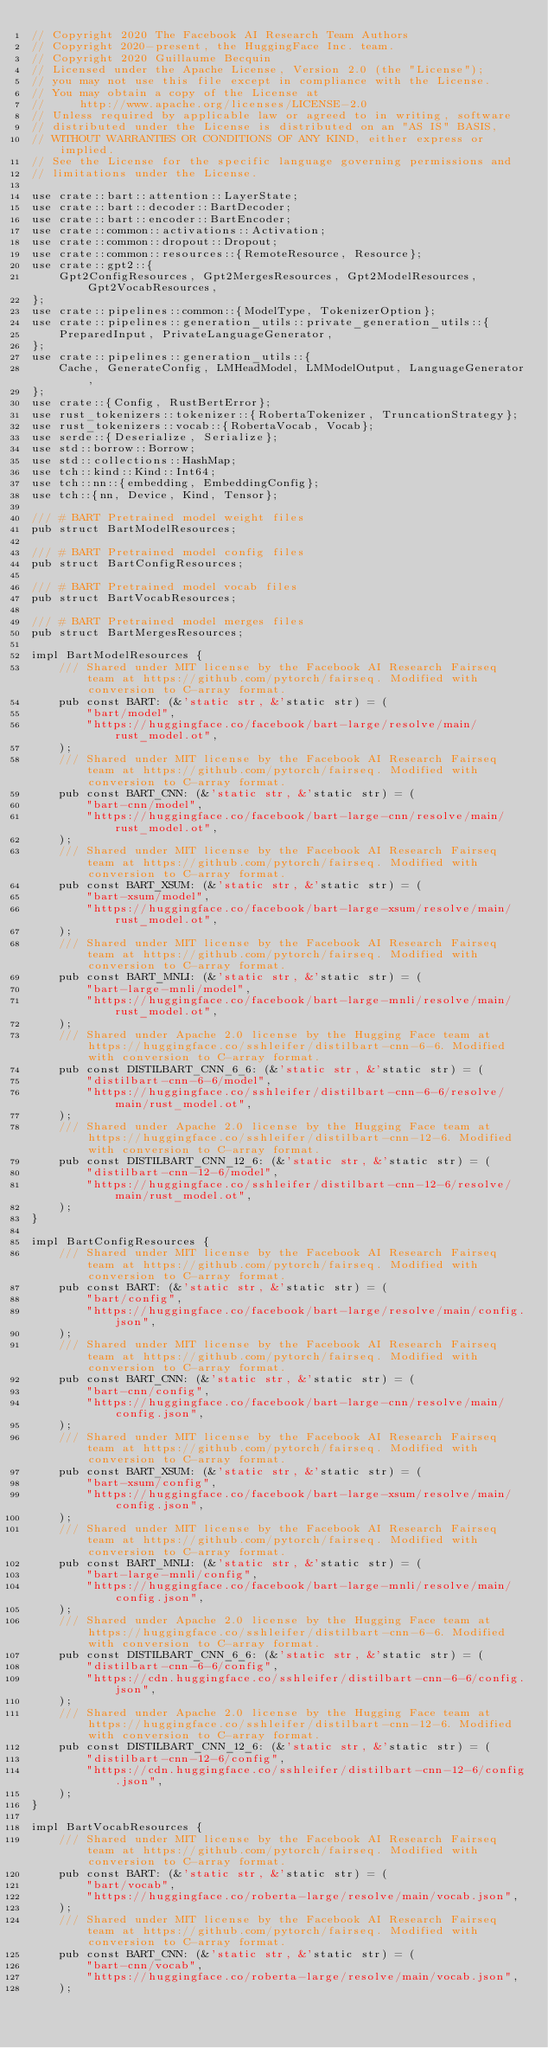<code> <loc_0><loc_0><loc_500><loc_500><_Rust_>// Copyright 2020 The Facebook AI Research Team Authors
// Copyright 2020-present, the HuggingFace Inc. team.
// Copyright 2020 Guillaume Becquin
// Licensed under the Apache License, Version 2.0 (the "License");
// you may not use this file except in compliance with the License.
// You may obtain a copy of the License at
//     http://www.apache.org/licenses/LICENSE-2.0
// Unless required by applicable law or agreed to in writing, software
// distributed under the License is distributed on an "AS IS" BASIS,
// WITHOUT WARRANTIES OR CONDITIONS OF ANY KIND, either express or implied.
// See the License for the specific language governing permissions and
// limitations under the License.

use crate::bart::attention::LayerState;
use crate::bart::decoder::BartDecoder;
use crate::bart::encoder::BartEncoder;
use crate::common::activations::Activation;
use crate::common::dropout::Dropout;
use crate::common::resources::{RemoteResource, Resource};
use crate::gpt2::{
    Gpt2ConfigResources, Gpt2MergesResources, Gpt2ModelResources, Gpt2VocabResources,
};
use crate::pipelines::common::{ModelType, TokenizerOption};
use crate::pipelines::generation_utils::private_generation_utils::{
    PreparedInput, PrivateLanguageGenerator,
};
use crate::pipelines::generation_utils::{
    Cache, GenerateConfig, LMHeadModel, LMModelOutput, LanguageGenerator,
};
use crate::{Config, RustBertError};
use rust_tokenizers::tokenizer::{RobertaTokenizer, TruncationStrategy};
use rust_tokenizers::vocab::{RobertaVocab, Vocab};
use serde::{Deserialize, Serialize};
use std::borrow::Borrow;
use std::collections::HashMap;
use tch::kind::Kind::Int64;
use tch::nn::{embedding, EmbeddingConfig};
use tch::{nn, Device, Kind, Tensor};

/// # BART Pretrained model weight files
pub struct BartModelResources;

/// # BART Pretrained model config files
pub struct BartConfigResources;

/// # BART Pretrained model vocab files
pub struct BartVocabResources;

/// # BART Pretrained model merges files
pub struct BartMergesResources;

impl BartModelResources {
    /// Shared under MIT license by the Facebook AI Research Fairseq team at https://github.com/pytorch/fairseq. Modified with conversion to C-array format.
    pub const BART: (&'static str, &'static str) = (
        "bart/model",
        "https://huggingface.co/facebook/bart-large/resolve/main/rust_model.ot",
    );
    /// Shared under MIT license by the Facebook AI Research Fairseq team at https://github.com/pytorch/fairseq. Modified with conversion to C-array format.
    pub const BART_CNN: (&'static str, &'static str) = (
        "bart-cnn/model",
        "https://huggingface.co/facebook/bart-large-cnn/resolve/main/rust_model.ot",
    );
    /// Shared under MIT license by the Facebook AI Research Fairseq team at https://github.com/pytorch/fairseq. Modified with conversion to C-array format.
    pub const BART_XSUM: (&'static str, &'static str) = (
        "bart-xsum/model",
        "https://huggingface.co/facebook/bart-large-xsum/resolve/main/rust_model.ot",
    );
    /// Shared under MIT license by the Facebook AI Research Fairseq team at https://github.com/pytorch/fairseq. Modified with conversion to C-array format.
    pub const BART_MNLI: (&'static str, &'static str) = (
        "bart-large-mnli/model",
        "https://huggingface.co/facebook/bart-large-mnli/resolve/main/rust_model.ot",
    );
    /// Shared under Apache 2.0 license by the Hugging Face team at https://huggingface.co/sshleifer/distilbart-cnn-6-6. Modified with conversion to C-array format.
    pub const DISTILBART_CNN_6_6: (&'static str, &'static str) = (
        "distilbart-cnn-6-6/model",
        "https://huggingface.co/sshleifer/distilbart-cnn-6-6/resolve/main/rust_model.ot",
    );
    /// Shared under Apache 2.0 license by the Hugging Face team at https://huggingface.co/sshleifer/distilbart-cnn-12-6. Modified with conversion to C-array format.
    pub const DISTILBART_CNN_12_6: (&'static str, &'static str) = (
        "distilbart-cnn-12-6/model",
        "https://huggingface.co/sshleifer/distilbart-cnn-12-6/resolve/main/rust_model.ot",
    );
}

impl BartConfigResources {
    /// Shared under MIT license by the Facebook AI Research Fairseq team at https://github.com/pytorch/fairseq. Modified with conversion to C-array format.
    pub const BART: (&'static str, &'static str) = (
        "bart/config",
        "https://huggingface.co/facebook/bart-large/resolve/main/config.json",
    );
    /// Shared under MIT license by the Facebook AI Research Fairseq team at https://github.com/pytorch/fairseq. Modified with conversion to C-array format.
    pub const BART_CNN: (&'static str, &'static str) = (
        "bart-cnn/config",
        "https://huggingface.co/facebook/bart-large-cnn/resolve/main/config.json",
    );
    /// Shared under MIT license by the Facebook AI Research Fairseq team at https://github.com/pytorch/fairseq. Modified with conversion to C-array format.
    pub const BART_XSUM: (&'static str, &'static str) = (
        "bart-xsum/config",
        "https://huggingface.co/facebook/bart-large-xsum/resolve/main/config.json",
    );
    /// Shared under MIT license by the Facebook AI Research Fairseq team at https://github.com/pytorch/fairseq. Modified with conversion to C-array format.
    pub const BART_MNLI: (&'static str, &'static str) = (
        "bart-large-mnli/config",
        "https://huggingface.co/facebook/bart-large-mnli/resolve/main/config.json",
    );
    /// Shared under Apache 2.0 license by the Hugging Face team at https://huggingface.co/sshleifer/distilbart-cnn-6-6. Modified with conversion to C-array format.
    pub const DISTILBART_CNN_6_6: (&'static str, &'static str) = (
        "distilbart-cnn-6-6/config",
        "https://cdn.huggingface.co/sshleifer/distilbart-cnn-6-6/config.json",
    );
    /// Shared under Apache 2.0 license by the Hugging Face team at https://huggingface.co/sshleifer/distilbart-cnn-12-6. Modified with conversion to C-array format.
    pub const DISTILBART_CNN_12_6: (&'static str, &'static str) = (
        "distilbart-cnn-12-6/config",
        "https://cdn.huggingface.co/sshleifer/distilbart-cnn-12-6/config.json",
    );
}

impl BartVocabResources {
    /// Shared under MIT license by the Facebook AI Research Fairseq team at https://github.com/pytorch/fairseq. Modified with conversion to C-array format.
    pub const BART: (&'static str, &'static str) = (
        "bart/vocab",
        "https://huggingface.co/roberta-large/resolve/main/vocab.json",
    );
    /// Shared under MIT license by the Facebook AI Research Fairseq team at https://github.com/pytorch/fairseq. Modified with conversion to C-array format.
    pub const BART_CNN: (&'static str, &'static str) = (
        "bart-cnn/vocab",
        "https://huggingface.co/roberta-large/resolve/main/vocab.json",
    );</code> 